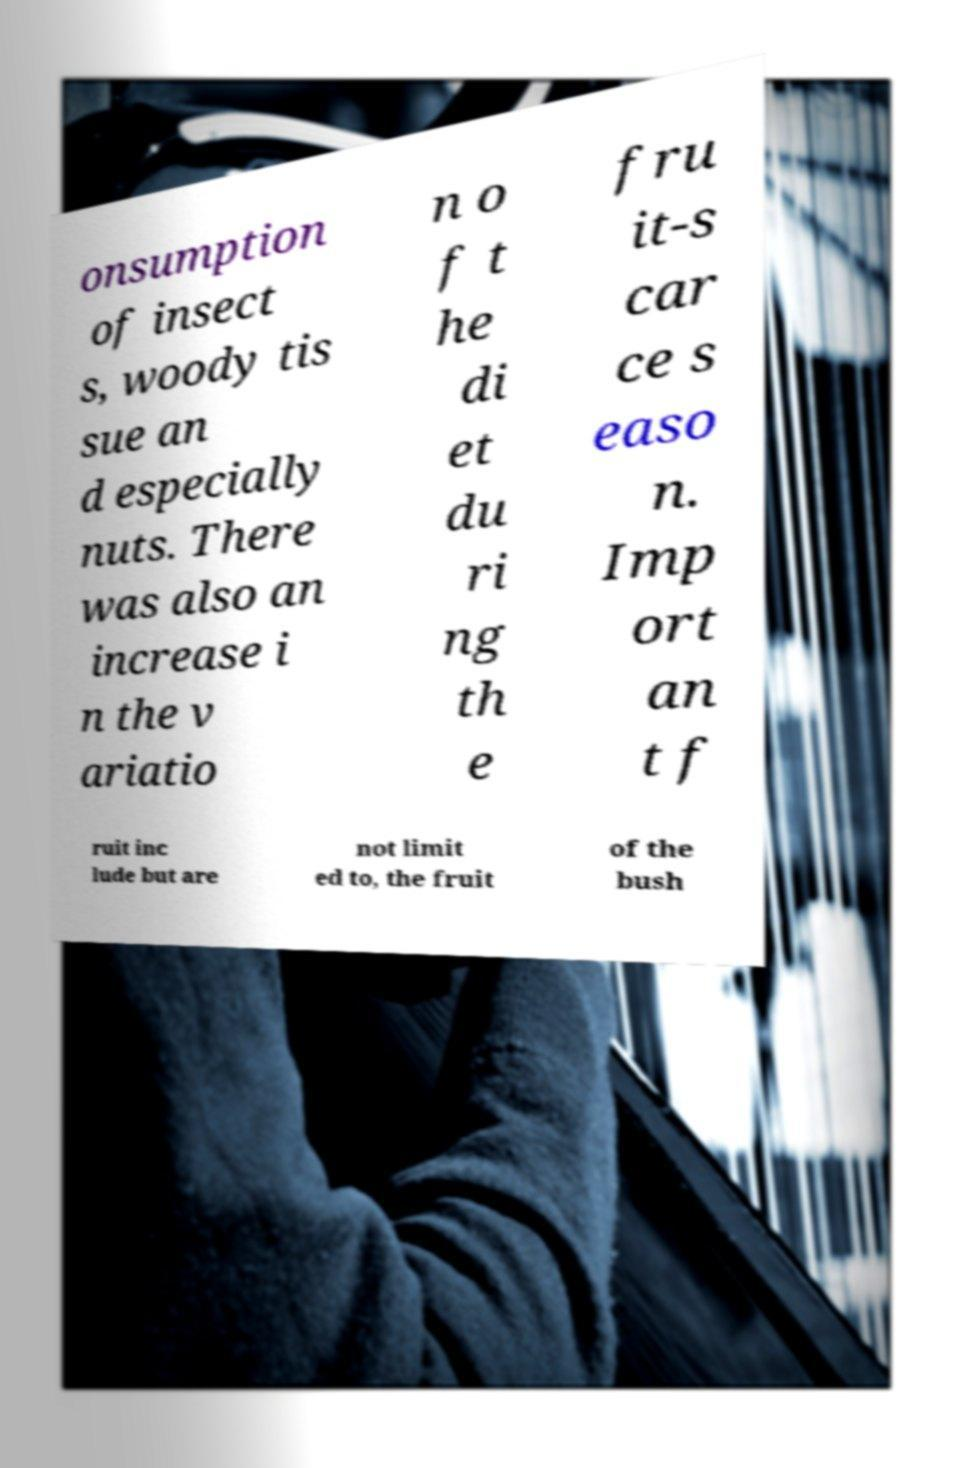Can you accurately transcribe the text from the provided image for me? onsumption of insect s, woody tis sue an d especially nuts. There was also an increase i n the v ariatio n o f t he di et du ri ng th e fru it-s car ce s easo n. Imp ort an t f ruit inc lude but are not limit ed to, the fruit of the bush 